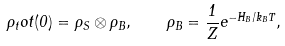Convert formula to latex. <formula><loc_0><loc_0><loc_500><loc_500>\rho _ { t } o t ( 0 ) = \rho _ { S } \otimes \rho _ { B } , \quad \rho _ { B } = \frac { 1 } { Z } e ^ { - H _ { B } / k _ { B } T } ,</formula> 